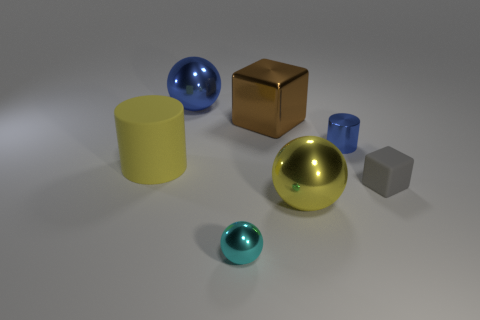Can you describe the relationship between the sizes of the different objects? Certainly! The blue sphere appears to be the largest object in size relative to the others. The gold cube is the next in size, followed by the yellow cylinder. The gray cube seems slightly larger than the small turquoise sphere, yet smaller than the other objects. 